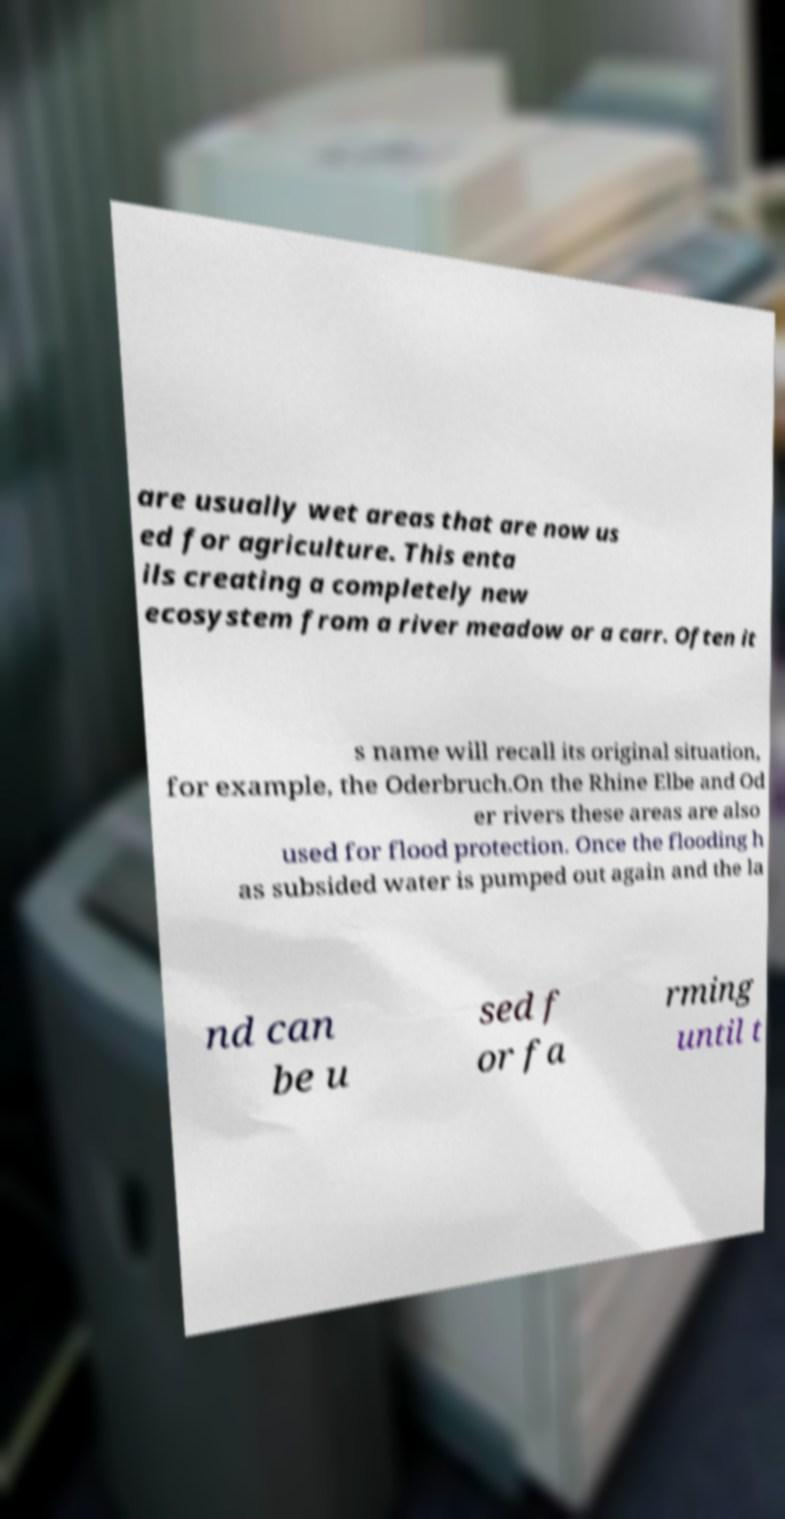Please read and relay the text visible in this image. What does it say? are usually wet areas that are now us ed for agriculture. This enta ils creating a completely new ecosystem from a river meadow or a carr. Often it s name will recall its original situation, for example, the Oderbruch.On the Rhine Elbe and Od er rivers these areas are also used for flood protection. Once the flooding h as subsided water is pumped out again and the la nd can be u sed f or fa rming until t 